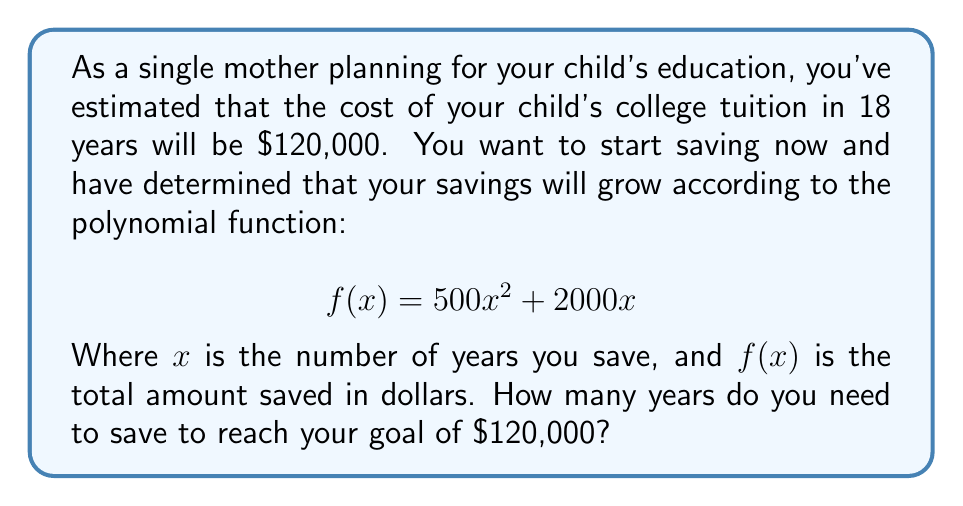Can you answer this question? To solve this problem, we need to find the roots of the equation:

$500x^2 + 2000x - 120000 = 0$

Let's solve this step-by-step:

1) First, we'll use the quadratic formula: $x = \frac{-b \pm \sqrt{b^2 - 4ac}}{2a}$

   Where $a = 500$, $b = 2000$, and $c = -120000$

2) Substituting these values into the quadratic formula:

   $x = \frac{-2000 \pm \sqrt{2000^2 - 4(500)(-120000)}}{2(500)}$

3) Simplify under the square root:

   $x = \frac{-2000 \pm \sqrt{4000000 + 240000000}}{1000}$
   
   $x = \frac{-2000 \pm \sqrt{244000000}}{1000}$

4) Simplify the square root:

   $x = \frac{-2000 \pm 15620}{1000}$

5) This gives us two solutions:

   $x = \frac{-2000 + 15620}{1000} = \frac{13620}{1000} = 13.62$
   
   $x = \frac{-2000 - 15620}{1000} = \frac{-17620}{1000} = -17.62$

6) Since we're dealing with years of saving, we can discard the negative solution.

Therefore, you need to save for approximately 13.62 years to reach your goal of $120,000.
Answer: Approximately 13.62 years 